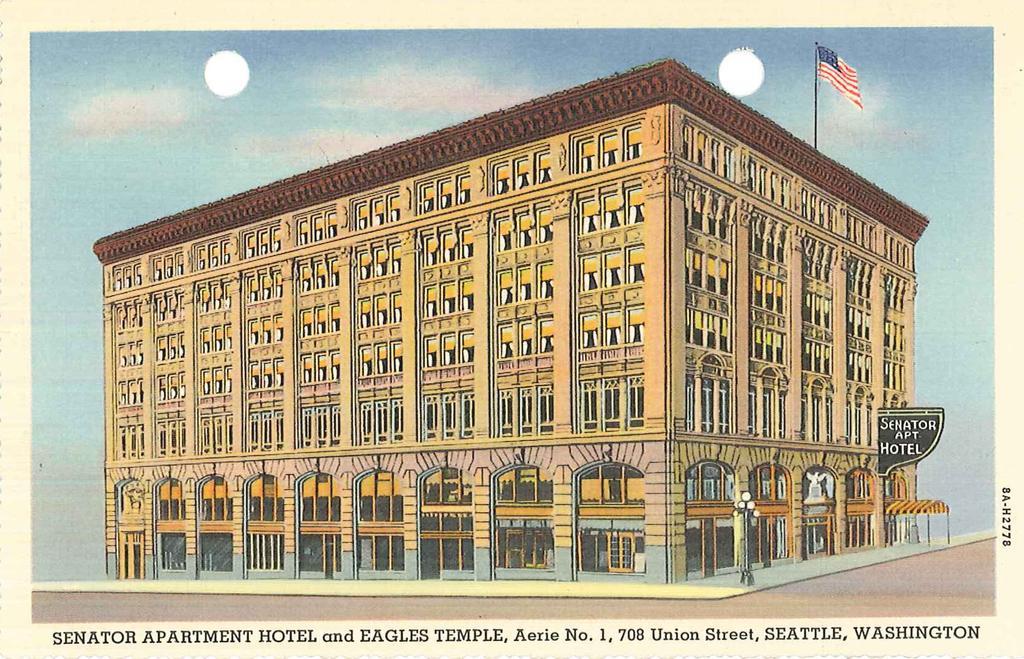Describe this image in one or two sentences. In this image there is a photograph, there is a building, there is the sky, there is a flag, there is a board, there is text on the board, there is pole, there are lights, there is text towards the bottom of the image, there is text towards the right of the image, there is the road, there is the door, there are windows. 